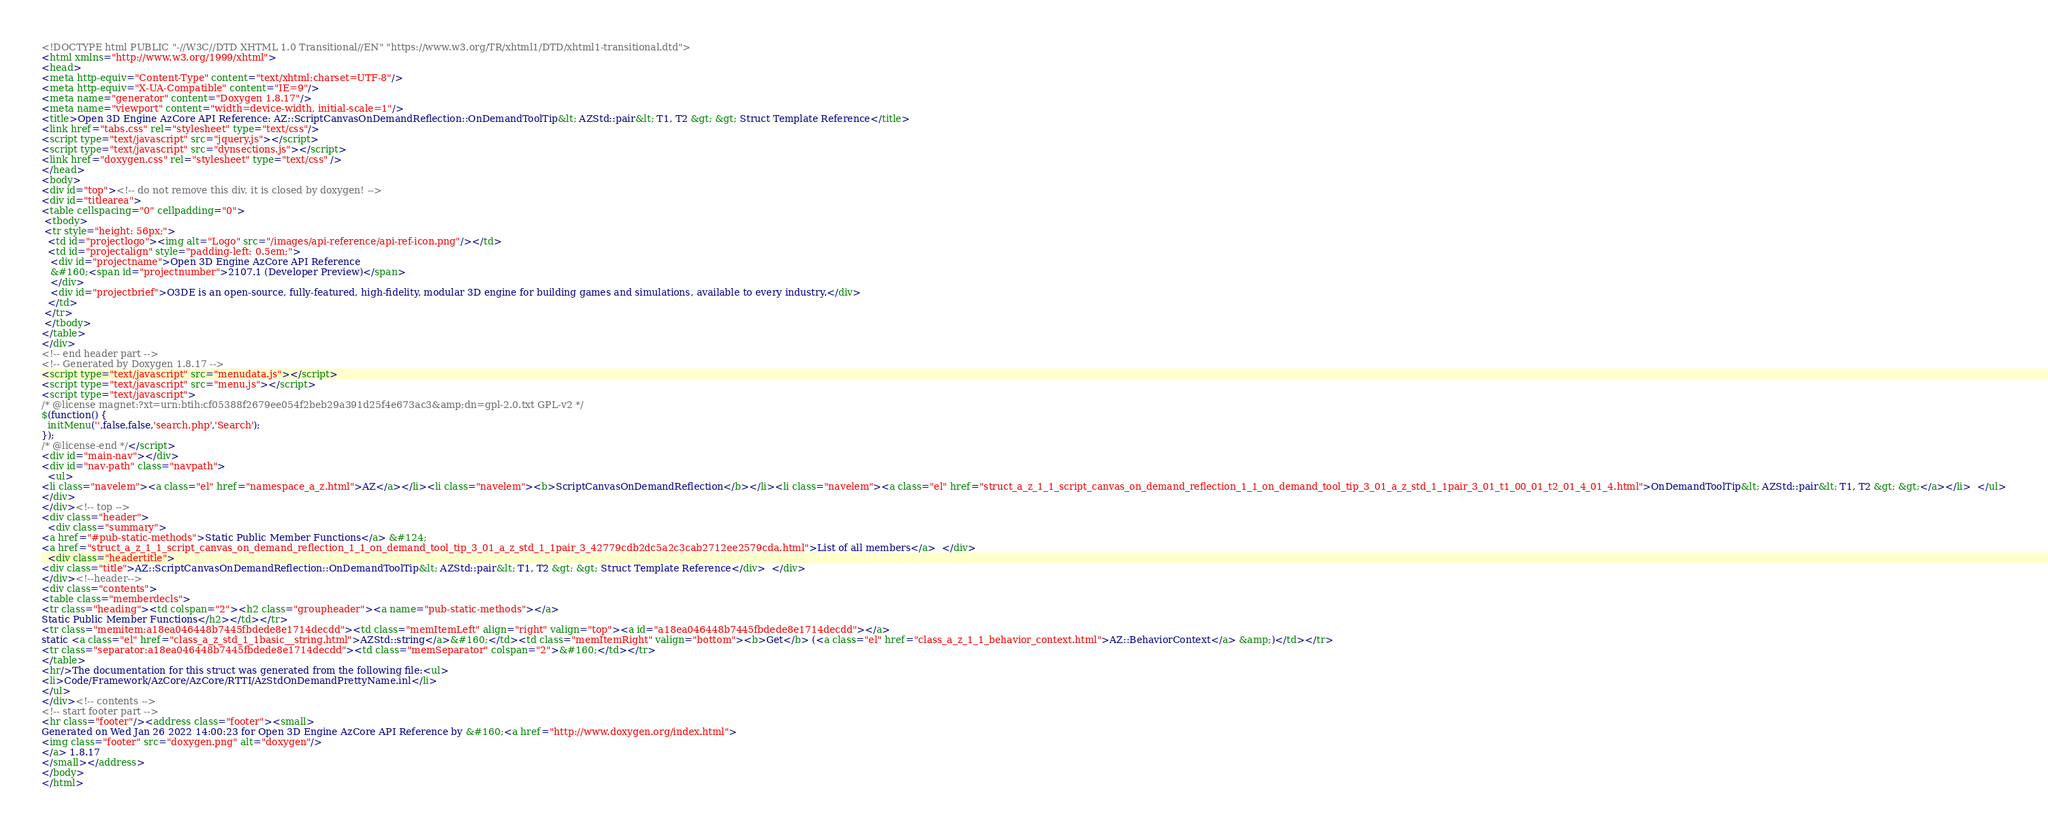<code> <loc_0><loc_0><loc_500><loc_500><_HTML_><!DOCTYPE html PUBLIC "-//W3C//DTD XHTML 1.0 Transitional//EN" "https://www.w3.org/TR/xhtml1/DTD/xhtml1-transitional.dtd">
<html xmlns="http://www.w3.org/1999/xhtml">
<head>
<meta http-equiv="Content-Type" content="text/xhtml;charset=UTF-8"/>
<meta http-equiv="X-UA-Compatible" content="IE=9"/>
<meta name="generator" content="Doxygen 1.8.17"/>
<meta name="viewport" content="width=device-width, initial-scale=1"/>
<title>Open 3D Engine AzCore API Reference: AZ::ScriptCanvasOnDemandReflection::OnDemandToolTip&lt; AZStd::pair&lt; T1, T2 &gt; &gt; Struct Template Reference</title>
<link href="tabs.css" rel="stylesheet" type="text/css"/>
<script type="text/javascript" src="jquery.js"></script>
<script type="text/javascript" src="dynsections.js"></script>
<link href="doxygen.css" rel="stylesheet" type="text/css" />
</head>
<body>
<div id="top"><!-- do not remove this div, it is closed by doxygen! -->
<div id="titlearea">
<table cellspacing="0" cellpadding="0">
 <tbody>
 <tr style="height: 56px;">
  <td id="projectlogo"><img alt="Logo" src="/images/api-reference/api-ref-icon.png"/></td>
  <td id="projectalign" style="padding-left: 0.5em;">
   <div id="projectname">Open 3D Engine AzCore API Reference
   &#160;<span id="projectnumber">2107.1 (Developer Preview)</span>
   </div>
   <div id="projectbrief">O3DE is an open-source, fully-featured, high-fidelity, modular 3D engine for building games and simulations, available to every industry.</div>
  </td>
 </tr>
 </tbody>
</table>
</div>
<!-- end header part -->
<!-- Generated by Doxygen 1.8.17 -->
<script type="text/javascript" src="menudata.js"></script>
<script type="text/javascript" src="menu.js"></script>
<script type="text/javascript">
/* @license magnet:?xt=urn:btih:cf05388f2679ee054f2beb29a391d25f4e673ac3&amp;dn=gpl-2.0.txt GPL-v2 */
$(function() {
  initMenu('',false,false,'search.php','Search');
});
/* @license-end */</script>
<div id="main-nav"></div>
<div id="nav-path" class="navpath">
  <ul>
<li class="navelem"><a class="el" href="namespace_a_z.html">AZ</a></li><li class="navelem"><b>ScriptCanvasOnDemandReflection</b></li><li class="navelem"><a class="el" href="struct_a_z_1_1_script_canvas_on_demand_reflection_1_1_on_demand_tool_tip_3_01_a_z_std_1_1pair_3_01_t1_00_01_t2_01_4_01_4.html">OnDemandToolTip&lt; AZStd::pair&lt; T1, T2 &gt; &gt;</a></li>  </ul>
</div>
</div><!-- top -->
<div class="header">
  <div class="summary">
<a href="#pub-static-methods">Static Public Member Functions</a> &#124;
<a href="struct_a_z_1_1_script_canvas_on_demand_reflection_1_1_on_demand_tool_tip_3_01_a_z_std_1_1pair_3_42779cdb2dc5a2c3cab2712ee2579cda.html">List of all members</a>  </div>
  <div class="headertitle">
<div class="title">AZ::ScriptCanvasOnDemandReflection::OnDemandToolTip&lt; AZStd::pair&lt; T1, T2 &gt; &gt; Struct Template Reference</div>  </div>
</div><!--header-->
<div class="contents">
<table class="memberdecls">
<tr class="heading"><td colspan="2"><h2 class="groupheader"><a name="pub-static-methods"></a>
Static Public Member Functions</h2></td></tr>
<tr class="memitem:a18ea046448b7445fbdede8e1714decdd"><td class="memItemLeft" align="right" valign="top"><a id="a18ea046448b7445fbdede8e1714decdd"></a>
static <a class="el" href="class_a_z_std_1_1basic__string.html">AZStd::string</a>&#160;</td><td class="memItemRight" valign="bottom"><b>Get</b> (<a class="el" href="class_a_z_1_1_behavior_context.html">AZ::BehaviorContext</a> &amp;)</td></tr>
<tr class="separator:a18ea046448b7445fbdede8e1714decdd"><td class="memSeparator" colspan="2">&#160;</td></tr>
</table>
<hr/>The documentation for this struct was generated from the following file:<ul>
<li>Code/Framework/AzCore/AzCore/RTTI/AzStdOnDemandPrettyName.inl</li>
</ul>
</div><!-- contents -->
<!-- start footer part -->
<hr class="footer"/><address class="footer"><small>
Generated on Wed Jan 26 2022 14:00:23 for Open 3D Engine AzCore API Reference by &#160;<a href="http://www.doxygen.org/index.html">
<img class="footer" src="doxygen.png" alt="doxygen"/>
</a> 1.8.17
</small></address>
</body>
</html>
</code> 